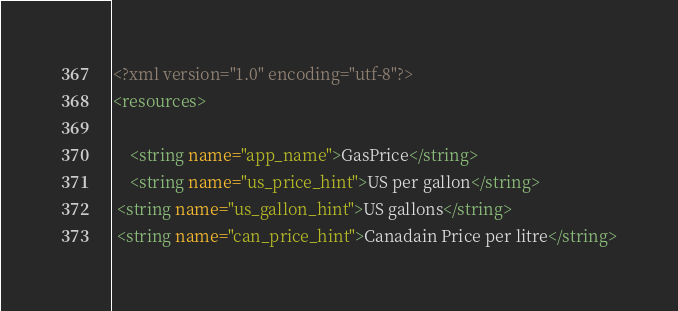<code> <loc_0><loc_0><loc_500><loc_500><_XML_><?xml version="1.0" encoding="utf-8"?>
<resources>

    <string name="app_name">GasPrice</string>
    <string name="us_price_hint">US per gallon</string>
 <string name="us_gallon_hint">US gallons</string>
 <string name="can_price_hint">Canadain Price per litre</string></code> 